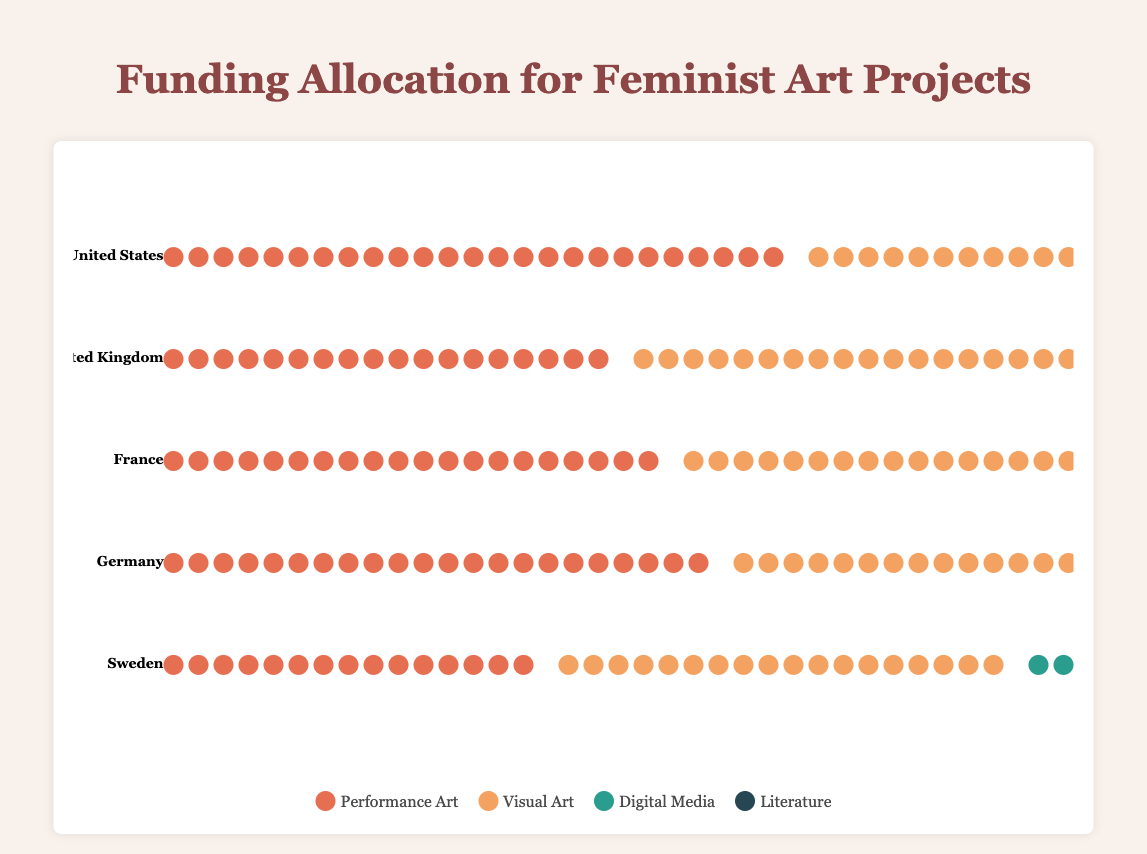What's the total funding allocated to Performance Art in all countries? To find this, sum the funding for Performance Art in each country: 250 (United States) + 180 (United Kingdom) + 200 (France) + 220 (Germany) + 150 (Sweden) = 1000
Answer: 1000 Which country allocated the most funding to Digital Media? Compare the funding allocated to Digital Media across all countries: 180 (United States), 150 (United Kingdom), 130 (France), 160 (Germany), 120 (Sweden). The United States has the highest allocation.
Answer: United States How much more funding does Visual Art receive compared to Literature in Germany? Subtract the funding for Literature from the funding for Visual Art in Germany: 260 (Visual Art) - 90 (Literature) = 170
Answer: 170 Which project type receives the least funding in Sweden? Look at the funding amounts for each project type in Sweden: 150 (Performance Art), 180 (Visual Art), 120 (Digital Media), 80 (Literature). Literature receives the least funding.
Answer: Literature How does the total funding for Visual Art compare between the United States and France? Compare the funding for Visual Art between the two countries: 300 (United States) - 240 (France) = 60. The United States allocates 60 more units of funding.
Answer: United States allocates 60 more What's the average funding allocated to Literature across all countries? Sum the funding for Literature in all countries and divide by the number of countries: (120 + 100 + 110 + 90 + 80) / 5 = 500 / 5 = 100
Answer: 100 Which country provides the least funding for Performance Art? Compare the funding amounts for Performance Art across all countries: 250 (United States), 180 (United Kingdom), 200 (France), 220 (Germany), 150 (Sweden). Sweden provides the least funding.
Answer: Sweden If all countries allocated an equal amount of funding to each project type, how much total funding would each country need to allocate? Sum the funding for each project type per country then divide by the number of countries: (300+220+240+260+180)/5 (Visual Art), (250+180+200+220+150)/5 (Performance Art), (180+150+130+160+120)/5 (Digital Media), (120+100+110+90+80)/5 (Literature) and then multiply by the number of project types: (240+200+148+100)*4
Answer: 6880 